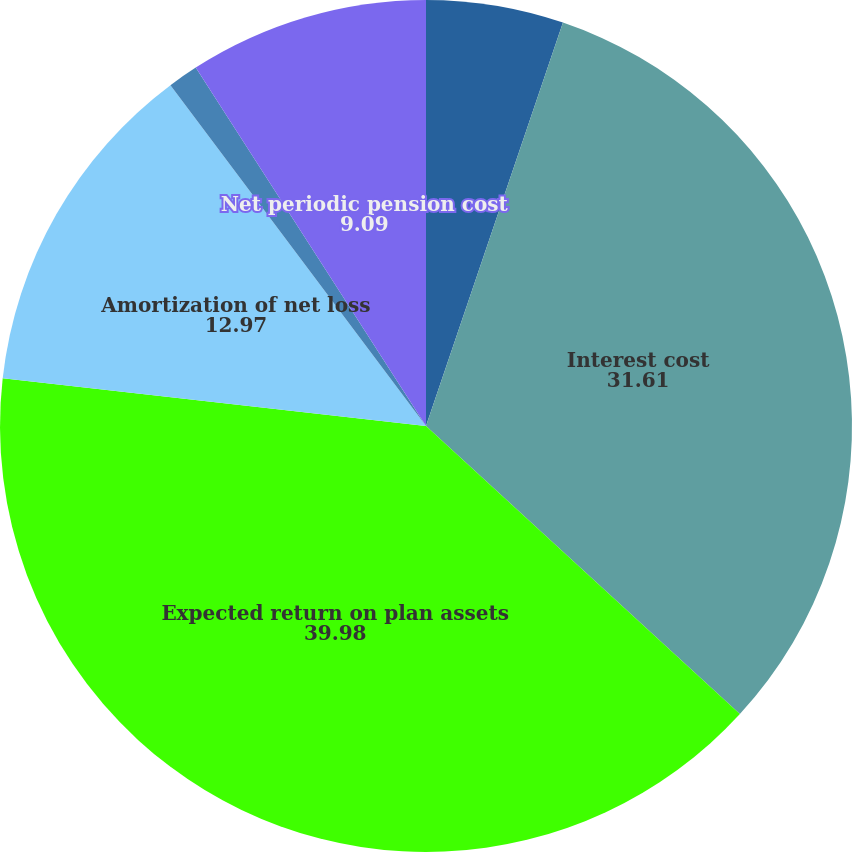Convert chart to OTSL. <chart><loc_0><loc_0><loc_500><loc_500><pie_chart><fcel>Service cost<fcel>Interest cost<fcel>Expected return on plan assets<fcel>Amortization of net loss<fcel>Curtailment and settlement<fcel>Net periodic pension cost<nl><fcel>5.21%<fcel>31.61%<fcel>39.98%<fcel>12.97%<fcel>1.15%<fcel>9.09%<nl></chart> 